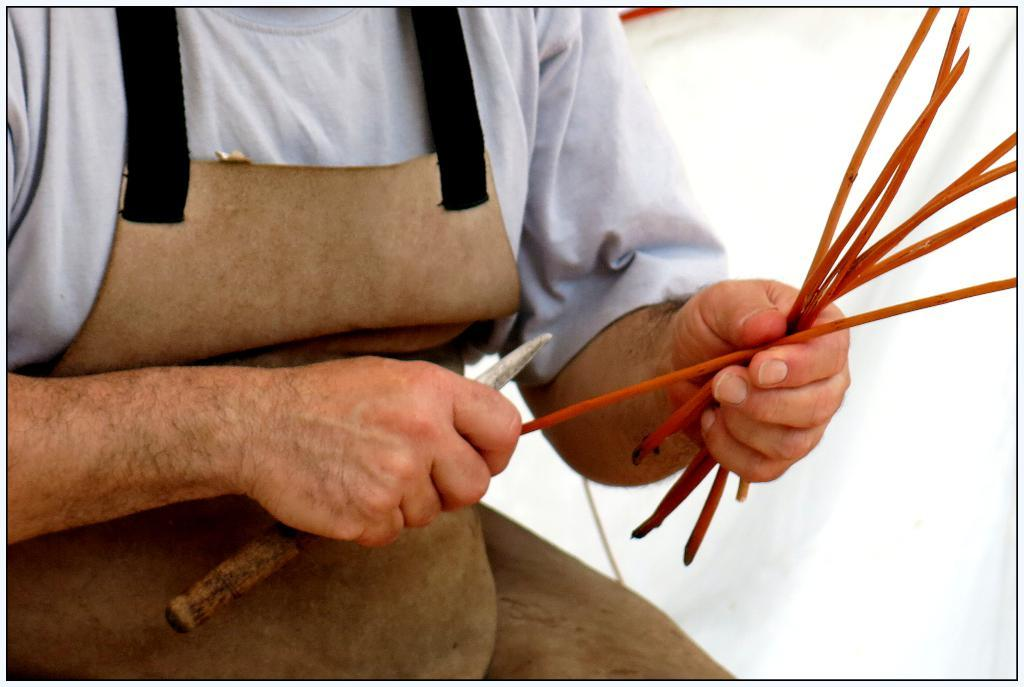What is the main subject of the image? There is a person in the image. What is the person holding in their hands? The person is holding a knife and sticks. What might the person be wearing to protect their clothing? The person is wearing an apron. How much of the person's body is visible in the image? The person is partially visible (truncated). What type of song can be heard playing in the background of the image? There is no indication of any sound or music in the image, so it is not possible to determine what song might be playing. 